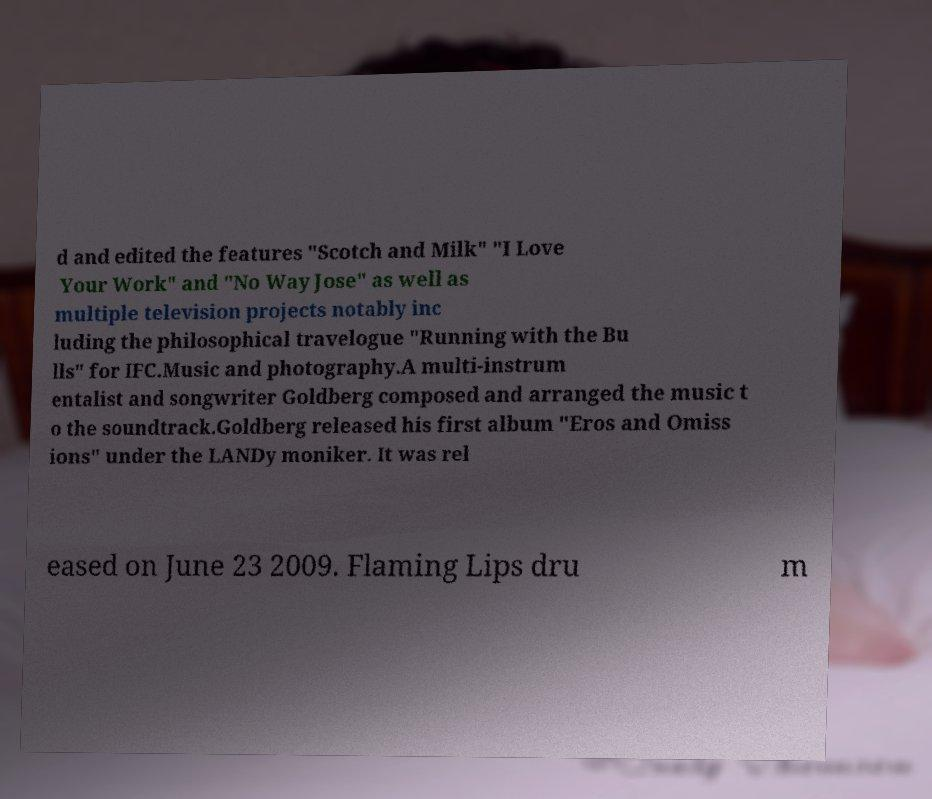Please read and relay the text visible in this image. What does it say? d and edited the features "Scotch and Milk" "I Love Your Work" and "No Way Jose" as well as multiple television projects notably inc luding the philosophical travelogue "Running with the Bu lls" for IFC.Music and photography.A multi-instrum entalist and songwriter Goldberg composed and arranged the music t o the soundtrack.Goldberg released his first album "Eros and Omiss ions" under the LANDy moniker. It was rel eased on June 23 2009. Flaming Lips dru m 